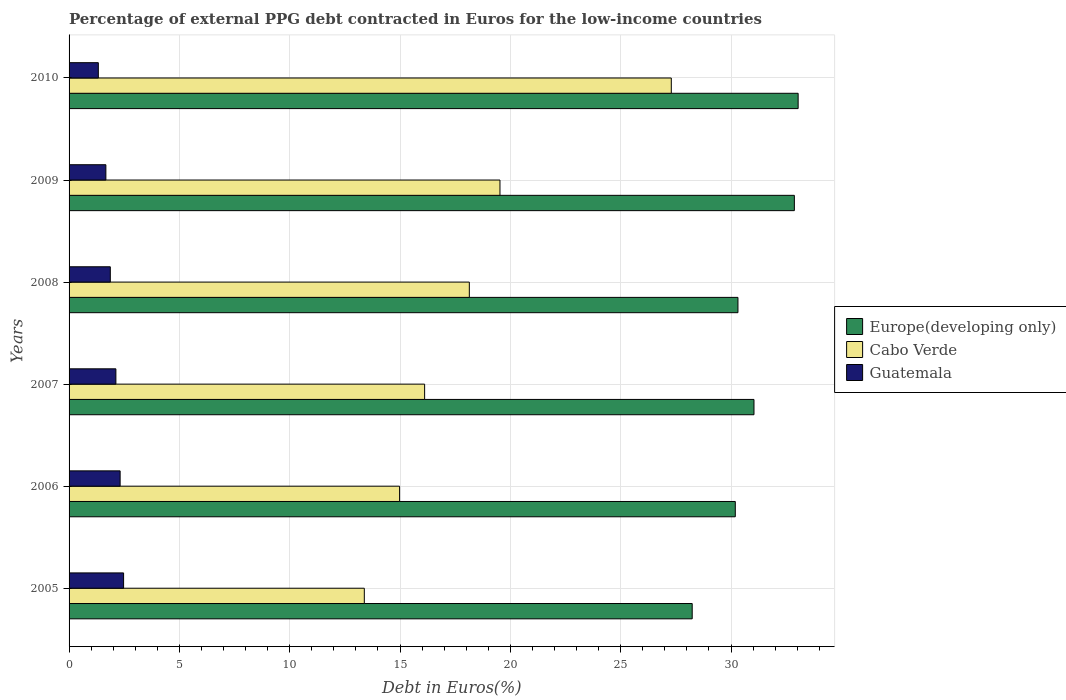Are the number of bars per tick equal to the number of legend labels?
Provide a succinct answer. Yes. How many bars are there on the 3rd tick from the top?
Make the answer very short. 3. What is the percentage of external PPG debt contracted in Euros in Cabo Verde in 2006?
Give a very brief answer. 14.98. Across all years, what is the maximum percentage of external PPG debt contracted in Euros in Cabo Verde?
Ensure brevity in your answer.  27.29. Across all years, what is the minimum percentage of external PPG debt contracted in Euros in Cabo Verde?
Make the answer very short. 13.38. What is the total percentage of external PPG debt contracted in Euros in Guatemala in the graph?
Give a very brief answer. 11.77. What is the difference between the percentage of external PPG debt contracted in Euros in Cabo Verde in 2006 and that in 2010?
Make the answer very short. -12.31. What is the difference between the percentage of external PPG debt contracted in Euros in Cabo Verde in 2010 and the percentage of external PPG debt contracted in Euros in Europe(developing only) in 2009?
Your answer should be very brief. -5.58. What is the average percentage of external PPG debt contracted in Euros in Guatemala per year?
Offer a very short reply. 1.96. In the year 2005, what is the difference between the percentage of external PPG debt contracted in Euros in Guatemala and percentage of external PPG debt contracted in Euros in Europe(developing only)?
Offer a very short reply. -25.77. What is the ratio of the percentage of external PPG debt contracted in Euros in Europe(developing only) in 2005 to that in 2008?
Your answer should be very brief. 0.93. What is the difference between the highest and the second highest percentage of external PPG debt contracted in Euros in Guatemala?
Offer a terse response. 0.16. What is the difference between the highest and the lowest percentage of external PPG debt contracted in Euros in Europe(developing only)?
Provide a succinct answer. 4.8. What does the 1st bar from the top in 2009 represents?
Your answer should be compact. Guatemala. What does the 2nd bar from the bottom in 2010 represents?
Provide a short and direct response. Cabo Verde. Is it the case that in every year, the sum of the percentage of external PPG debt contracted in Euros in Guatemala and percentage of external PPG debt contracted in Euros in Europe(developing only) is greater than the percentage of external PPG debt contracted in Euros in Cabo Verde?
Ensure brevity in your answer.  Yes. How many bars are there?
Your answer should be compact. 18. Are all the bars in the graph horizontal?
Your answer should be compact. Yes. What is the difference between two consecutive major ticks on the X-axis?
Your response must be concise. 5. Does the graph contain grids?
Ensure brevity in your answer.  Yes. Where does the legend appear in the graph?
Give a very brief answer. Center right. How are the legend labels stacked?
Make the answer very short. Vertical. What is the title of the graph?
Provide a succinct answer. Percentage of external PPG debt contracted in Euros for the low-income countries. What is the label or title of the X-axis?
Your answer should be very brief. Debt in Euros(%). What is the label or title of the Y-axis?
Your answer should be compact. Years. What is the Debt in Euros(%) of Europe(developing only) in 2005?
Your answer should be very brief. 28.24. What is the Debt in Euros(%) in Cabo Verde in 2005?
Offer a terse response. 13.38. What is the Debt in Euros(%) in Guatemala in 2005?
Offer a terse response. 2.47. What is the Debt in Euros(%) of Europe(developing only) in 2006?
Ensure brevity in your answer.  30.19. What is the Debt in Euros(%) in Cabo Verde in 2006?
Keep it short and to the point. 14.98. What is the Debt in Euros(%) in Guatemala in 2006?
Make the answer very short. 2.31. What is the Debt in Euros(%) of Europe(developing only) in 2007?
Offer a very short reply. 31.04. What is the Debt in Euros(%) of Cabo Verde in 2007?
Offer a terse response. 16.11. What is the Debt in Euros(%) in Guatemala in 2007?
Ensure brevity in your answer.  2.12. What is the Debt in Euros(%) in Europe(developing only) in 2008?
Provide a succinct answer. 30.31. What is the Debt in Euros(%) of Cabo Verde in 2008?
Provide a succinct answer. 18.14. What is the Debt in Euros(%) of Guatemala in 2008?
Make the answer very short. 1.87. What is the Debt in Euros(%) of Europe(developing only) in 2009?
Your response must be concise. 32.87. What is the Debt in Euros(%) in Cabo Verde in 2009?
Make the answer very short. 19.53. What is the Debt in Euros(%) of Guatemala in 2009?
Your answer should be very brief. 1.67. What is the Debt in Euros(%) of Europe(developing only) in 2010?
Offer a very short reply. 33.04. What is the Debt in Euros(%) in Cabo Verde in 2010?
Your answer should be very brief. 27.29. What is the Debt in Euros(%) in Guatemala in 2010?
Make the answer very short. 1.33. Across all years, what is the maximum Debt in Euros(%) in Europe(developing only)?
Provide a succinct answer. 33.04. Across all years, what is the maximum Debt in Euros(%) in Cabo Verde?
Make the answer very short. 27.29. Across all years, what is the maximum Debt in Euros(%) in Guatemala?
Keep it short and to the point. 2.47. Across all years, what is the minimum Debt in Euros(%) of Europe(developing only)?
Keep it short and to the point. 28.24. Across all years, what is the minimum Debt in Euros(%) of Cabo Verde?
Offer a terse response. 13.38. Across all years, what is the minimum Debt in Euros(%) in Guatemala?
Keep it short and to the point. 1.33. What is the total Debt in Euros(%) in Europe(developing only) in the graph?
Make the answer very short. 185.71. What is the total Debt in Euros(%) in Cabo Verde in the graph?
Your answer should be very brief. 109.44. What is the total Debt in Euros(%) in Guatemala in the graph?
Keep it short and to the point. 11.77. What is the difference between the Debt in Euros(%) of Europe(developing only) in 2005 and that in 2006?
Your response must be concise. -1.95. What is the difference between the Debt in Euros(%) of Cabo Verde in 2005 and that in 2006?
Offer a very short reply. -1.6. What is the difference between the Debt in Euros(%) in Guatemala in 2005 and that in 2006?
Your answer should be very brief. 0.16. What is the difference between the Debt in Euros(%) in Europe(developing only) in 2005 and that in 2007?
Make the answer very short. -2.8. What is the difference between the Debt in Euros(%) of Cabo Verde in 2005 and that in 2007?
Give a very brief answer. -2.73. What is the difference between the Debt in Euros(%) in Guatemala in 2005 and that in 2007?
Make the answer very short. 0.35. What is the difference between the Debt in Euros(%) of Europe(developing only) in 2005 and that in 2008?
Your answer should be compact. -2.07. What is the difference between the Debt in Euros(%) of Cabo Verde in 2005 and that in 2008?
Provide a succinct answer. -4.76. What is the difference between the Debt in Euros(%) in Guatemala in 2005 and that in 2008?
Make the answer very short. 0.6. What is the difference between the Debt in Euros(%) of Europe(developing only) in 2005 and that in 2009?
Your answer should be compact. -4.63. What is the difference between the Debt in Euros(%) of Cabo Verde in 2005 and that in 2009?
Provide a succinct answer. -6.15. What is the difference between the Debt in Euros(%) of Guatemala in 2005 and that in 2009?
Give a very brief answer. 0.8. What is the difference between the Debt in Euros(%) of Europe(developing only) in 2005 and that in 2010?
Your response must be concise. -4.8. What is the difference between the Debt in Euros(%) of Cabo Verde in 2005 and that in 2010?
Your answer should be compact. -13.91. What is the difference between the Debt in Euros(%) of Guatemala in 2005 and that in 2010?
Offer a terse response. 1.14. What is the difference between the Debt in Euros(%) of Europe(developing only) in 2006 and that in 2007?
Offer a very short reply. -0.85. What is the difference between the Debt in Euros(%) of Cabo Verde in 2006 and that in 2007?
Your answer should be very brief. -1.14. What is the difference between the Debt in Euros(%) of Guatemala in 2006 and that in 2007?
Ensure brevity in your answer.  0.19. What is the difference between the Debt in Euros(%) in Europe(developing only) in 2006 and that in 2008?
Provide a succinct answer. -0.12. What is the difference between the Debt in Euros(%) in Cabo Verde in 2006 and that in 2008?
Keep it short and to the point. -3.16. What is the difference between the Debt in Euros(%) in Guatemala in 2006 and that in 2008?
Your response must be concise. 0.44. What is the difference between the Debt in Euros(%) in Europe(developing only) in 2006 and that in 2009?
Keep it short and to the point. -2.68. What is the difference between the Debt in Euros(%) in Cabo Verde in 2006 and that in 2009?
Your answer should be compact. -4.55. What is the difference between the Debt in Euros(%) in Guatemala in 2006 and that in 2009?
Ensure brevity in your answer.  0.65. What is the difference between the Debt in Euros(%) in Europe(developing only) in 2006 and that in 2010?
Your answer should be compact. -2.85. What is the difference between the Debt in Euros(%) of Cabo Verde in 2006 and that in 2010?
Provide a short and direct response. -12.31. What is the difference between the Debt in Euros(%) in Guatemala in 2006 and that in 2010?
Provide a short and direct response. 0.99. What is the difference between the Debt in Euros(%) in Europe(developing only) in 2007 and that in 2008?
Provide a short and direct response. 0.73. What is the difference between the Debt in Euros(%) of Cabo Verde in 2007 and that in 2008?
Offer a very short reply. -2.03. What is the difference between the Debt in Euros(%) in Guatemala in 2007 and that in 2008?
Provide a succinct answer. 0.25. What is the difference between the Debt in Euros(%) in Europe(developing only) in 2007 and that in 2009?
Keep it short and to the point. -1.83. What is the difference between the Debt in Euros(%) of Cabo Verde in 2007 and that in 2009?
Your answer should be very brief. -3.42. What is the difference between the Debt in Euros(%) of Guatemala in 2007 and that in 2009?
Provide a short and direct response. 0.45. What is the difference between the Debt in Euros(%) in Europe(developing only) in 2007 and that in 2010?
Make the answer very short. -2. What is the difference between the Debt in Euros(%) in Cabo Verde in 2007 and that in 2010?
Your answer should be very brief. -11.18. What is the difference between the Debt in Euros(%) of Guatemala in 2007 and that in 2010?
Offer a very short reply. 0.8. What is the difference between the Debt in Euros(%) in Europe(developing only) in 2008 and that in 2009?
Offer a very short reply. -2.56. What is the difference between the Debt in Euros(%) of Cabo Verde in 2008 and that in 2009?
Your answer should be compact. -1.39. What is the difference between the Debt in Euros(%) in Guatemala in 2008 and that in 2009?
Keep it short and to the point. 0.2. What is the difference between the Debt in Euros(%) in Europe(developing only) in 2008 and that in 2010?
Your answer should be compact. -2.73. What is the difference between the Debt in Euros(%) of Cabo Verde in 2008 and that in 2010?
Ensure brevity in your answer.  -9.15. What is the difference between the Debt in Euros(%) in Guatemala in 2008 and that in 2010?
Ensure brevity in your answer.  0.54. What is the difference between the Debt in Euros(%) in Europe(developing only) in 2009 and that in 2010?
Provide a succinct answer. -0.17. What is the difference between the Debt in Euros(%) of Cabo Verde in 2009 and that in 2010?
Offer a terse response. -7.76. What is the difference between the Debt in Euros(%) in Guatemala in 2009 and that in 2010?
Provide a succinct answer. 0.34. What is the difference between the Debt in Euros(%) of Europe(developing only) in 2005 and the Debt in Euros(%) of Cabo Verde in 2006?
Provide a short and direct response. 13.26. What is the difference between the Debt in Euros(%) in Europe(developing only) in 2005 and the Debt in Euros(%) in Guatemala in 2006?
Offer a very short reply. 25.93. What is the difference between the Debt in Euros(%) in Cabo Verde in 2005 and the Debt in Euros(%) in Guatemala in 2006?
Your response must be concise. 11.07. What is the difference between the Debt in Euros(%) of Europe(developing only) in 2005 and the Debt in Euros(%) of Cabo Verde in 2007?
Provide a short and direct response. 12.13. What is the difference between the Debt in Euros(%) in Europe(developing only) in 2005 and the Debt in Euros(%) in Guatemala in 2007?
Ensure brevity in your answer.  26.12. What is the difference between the Debt in Euros(%) of Cabo Verde in 2005 and the Debt in Euros(%) of Guatemala in 2007?
Your response must be concise. 11.26. What is the difference between the Debt in Euros(%) in Europe(developing only) in 2005 and the Debt in Euros(%) in Cabo Verde in 2008?
Offer a very short reply. 10.1. What is the difference between the Debt in Euros(%) in Europe(developing only) in 2005 and the Debt in Euros(%) in Guatemala in 2008?
Provide a short and direct response. 26.37. What is the difference between the Debt in Euros(%) in Cabo Verde in 2005 and the Debt in Euros(%) in Guatemala in 2008?
Ensure brevity in your answer.  11.51. What is the difference between the Debt in Euros(%) of Europe(developing only) in 2005 and the Debt in Euros(%) of Cabo Verde in 2009?
Make the answer very short. 8.71. What is the difference between the Debt in Euros(%) of Europe(developing only) in 2005 and the Debt in Euros(%) of Guatemala in 2009?
Give a very brief answer. 26.57. What is the difference between the Debt in Euros(%) in Cabo Verde in 2005 and the Debt in Euros(%) in Guatemala in 2009?
Make the answer very short. 11.71. What is the difference between the Debt in Euros(%) in Europe(developing only) in 2005 and the Debt in Euros(%) in Cabo Verde in 2010?
Offer a very short reply. 0.95. What is the difference between the Debt in Euros(%) of Europe(developing only) in 2005 and the Debt in Euros(%) of Guatemala in 2010?
Your response must be concise. 26.92. What is the difference between the Debt in Euros(%) in Cabo Verde in 2005 and the Debt in Euros(%) in Guatemala in 2010?
Your response must be concise. 12.05. What is the difference between the Debt in Euros(%) of Europe(developing only) in 2006 and the Debt in Euros(%) of Cabo Verde in 2007?
Ensure brevity in your answer.  14.08. What is the difference between the Debt in Euros(%) in Europe(developing only) in 2006 and the Debt in Euros(%) in Guatemala in 2007?
Your answer should be very brief. 28.07. What is the difference between the Debt in Euros(%) of Cabo Verde in 2006 and the Debt in Euros(%) of Guatemala in 2007?
Your answer should be compact. 12.86. What is the difference between the Debt in Euros(%) in Europe(developing only) in 2006 and the Debt in Euros(%) in Cabo Verde in 2008?
Your response must be concise. 12.05. What is the difference between the Debt in Euros(%) of Europe(developing only) in 2006 and the Debt in Euros(%) of Guatemala in 2008?
Offer a very short reply. 28.33. What is the difference between the Debt in Euros(%) of Cabo Verde in 2006 and the Debt in Euros(%) of Guatemala in 2008?
Provide a succinct answer. 13.11. What is the difference between the Debt in Euros(%) in Europe(developing only) in 2006 and the Debt in Euros(%) in Cabo Verde in 2009?
Your answer should be compact. 10.66. What is the difference between the Debt in Euros(%) in Europe(developing only) in 2006 and the Debt in Euros(%) in Guatemala in 2009?
Give a very brief answer. 28.53. What is the difference between the Debt in Euros(%) of Cabo Verde in 2006 and the Debt in Euros(%) of Guatemala in 2009?
Make the answer very short. 13.31. What is the difference between the Debt in Euros(%) of Europe(developing only) in 2006 and the Debt in Euros(%) of Cabo Verde in 2010?
Provide a succinct answer. 2.9. What is the difference between the Debt in Euros(%) of Europe(developing only) in 2006 and the Debt in Euros(%) of Guatemala in 2010?
Provide a succinct answer. 28.87. What is the difference between the Debt in Euros(%) in Cabo Verde in 2006 and the Debt in Euros(%) in Guatemala in 2010?
Give a very brief answer. 13.65. What is the difference between the Debt in Euros(%) in Europe(developing only) in 2007 and the Debt in Euros(%) in Cabo Verde in 2008?
Ensure brevity in your answer.  12.9. What is the difference between the Debt in Euros(%) in Europe(developing only) in 2007 and the Debt in Euros(%) in Guatemala in 2008?
Provide a succinct answer. 29.17. What is the difference between the Debt in Euros(%) of Cabo Verde in 2007 and the Debt in Euros(%) of Guatemala in 2008?
Your answer should be compact. 14.25. What is the difference between the Debt in Euros(%) of Europe(developing only) in 2007 and the Debt in Euros(%) of Cabo Verde in 2009?
Provide a short and direct response. 11.51. What is the difference between the Debt in Euros(%) of Europe(developing only) in 2007 and the Debt in Euros(%) of Guatemala in 2009?
Offer a very short reply. 29.37. What is the difference between the Debt in Euros(%) in Cabo Verde in 2007 and the Debt in Euros(%) in Guatemala in 2009?
Your response must be concise. 14.45. What is the difference between the Debt in Euros(%) in Europe(developing only) in 2007 and the Debt in Euros(%) in Cabo Verde in 2010?
Provide a short and direct response. 3.75. What is the difference between the Debt in Euros(%) in Europe(developing only) in 2007 and the Debt in Euros(%) in Guatemala in 2010?
Keep it short and to the point. 29.72. What is the difference between the Debt in Euros(%) of Cabo Verde in 2007 and the Debt in Euros(%) of Guatemala in 2010?
Offer a very short reply. 14.79. What is the difference between the Debt in Euros(%) in Europe(developing only) in 2008 and the Debt in Euros(%) in Cabo Verde in 2009?
Offer a terse response. 10.79. What is the difference between the Debt in Euros(%) in Europe(developing only) in 2008 and the Debt in Euros(%) in Guatemala in 2009?
Keep it short and to the point. 28.65. What is the difference between the Debt in Euros(%) of Cabo Verde in 2008 and the Debt in Euros(%) of Guatemala in 2009?
Offer a very short reply. 16.47. What is the difference between the Debt in Euros(%) in Europe(developing only) in 2008 and the Debt in Euros(%) in Cabo Verde in 2010?
Your response must be concise. 3.02. What is the difference between the Debt in Euros(%) of Europe(developing only) in 2008 and the Debt in Euros(%) of Guatemala in 2010?
Your answer should be very brief. 28.99. What is the difference between the Debt in Euros(%) in Cabo Verde in 2008 and the Debt in Euros(%) in Guatemala in 2010?
Offer a very short reply. 16.81. What is the difference between the Debt in Euros(%) in Europe(developing only) in 2009 and the Debt in Euros(%) in Cabo Verde in 2010?
Offer a very short reply. 5.58. What is the difference between the Debt in Euros(%) of Europe(developing only) in 2009 and the Debt in Euros(%) of Guatemala in 2010?
Give a very brief answer. 31.55. What is the difference between the Debt in Euros(%) of Cabo Verde in 2009 and the Debt in Euros(%) of Guatemala in 2010?
Your answer should be compact. 18.2. What is the average Debt in Euros(%) of Europe(developing only) per year?
Your response must be concise. 30.95. What is the average Debt in Euros(%) of Cabo Verde per year?
Provide a succinct answer. 18.24. What is the average Debt in Euros(%) in Guatemala per year?
Offer a terse response. 1.96. In the year 2005, what is the difference between the Debt in Euros(%) of Europe(developing only) and Debt in Euros(%) of Cabo Verde?
Offer a terse response. 14.86. In the year 2005, what is the difference between the Debt in Euros(%) in Europe(developing only) and Debt in Euros(%) in Guatemala?
Offer a terse response. 25.77. In the year 2005, what is the difference between the Debt in Euros(%) in Cabo Verde and Debt in Euros(%) in Guatemala?
Your response must be concise. 10.91. In the year 2006, what is the difference between the Debt in Euros(%) in Europe(developing only) and Debt in Euros(%) in Cabo Verde?
Your answer should be very brief. 15.22. In the year 2006, what is the difference between the Debt in Euros(%) in Europe(developing only) and Debt in Euros(%) in Guatemala?
Offer a very short reply. 27.88. In the year 2006, what is the difference between the Debt in Euros(%) of Cabo Verde and Debt in Euros(%) of Guatemala?
Offer a very short reply. 12.67. In the year 2007, what is the difference between the Debt in Euros(%) in Europe(developing only) and Debt in Euros(%) in Cabo Verde?
Ensure brevity in your answer.  14.93. In the year 2007, what is the difference between the Debt in Euros(%) of Europe(developing only) and Debt in Euros(%) of Guatemala?
Your response must be concise. 28.92. In the year 2007, what is the difference between the Debt in Euros(%) of Cabo Verde and Debt in Euros(%) of Guatemala?
Give a very brief answer. 13.99. In the year 2008, what is the difference between the Debt in Euros(%) in Europe(developing only) and Debt in Euros(%) in Cabo Verde?
Your answer should be very brief. 12.17. In the year 2008, what is the difference between the Debt in Euros(%) of Europe(developing only) and Debt in Euros(%) of Guatemala?
Provide a short and direct response. 28.45. In the year 2008, what is the difference between the Debt in Euros(%) of Cabo Verde and Debt in Euros(%) of Guatemala?
Provide a short and direct response. 16.27. In the year 2009, what is the difference between the Debt in Euros(%) in Europe(developing only) and Debt in Euros(%) in Cabo Verde?
Offer a terse response. 13.34. In the year 2009, what is the difference between the Debt in Euros(%) of Europe(developing only) and Debt in Euros(%) of Guatemala?
Your answer should be compact. 31.2. In the year 2009, what is the difference between the Debt in Euros(%) of Cabo Verde and Debt in Euros(%) of Guatemala?
Give a very brief answer. 17.86. In the year 2010, what is the difference between the Debt in Euros(%) of Europe(developing only) and Debt in Euros(%) of Cabo Verde?
Offer a terse response. 5.75. In the year 2010, what is the difference between the Debt in Euros(%) in Europe(developing only) and Debt in Euros(%) in Guatemala?
Your answer should be very brief. 31.72. In the year 2010, what is the difference between the Debt in Euros(%) of Cabo Verde and Debt in Euros(%) of Guatemala?
Provide a short and direct response. 25.97. What is the ratio of the Debt in Euros(%) in Europe(developing only) in 2005 to that in 2006?
Your answer should be very brief. 0.94. What is the ratio of the Debt in Euros(%) of Cabo Verde in 2005 to that in 2006?
Your answer should be compact. 0.89. What is the ratio of the Debt in Euros(%) of Guatemala in 2005 to that in 2006?
Keep it short and to the point. 1.07. What is the ratio of the Debt in Euros(%) in Europe(developing only) in 2005 to that in 2007?
Provide a succinct answer. 0.91. What is the ratio of the Debt in Euros(%) of Cabo Verde in 2005 to that in 2007?
Your response must be concise. 0.83. What is the ratio of the Debt in Euros(%) in Guatemala in 2005 to that in 2007?
Offer a terse response. 1.16. What is the ratio of the Debt in Euros(%) in Europe(developing only) in 2005 to that in 2008?
Provide a succinct answer. 0.93. What is the ratio of the Debt in Euros(%) of Cabo Verde in 2005 to that in 2008?
Provide a short and direct response. 0.74. What is the ratio of the Debt in Euros(%) of Guatemala in 2005 to that in 2008?
Provide a succinct answer. 1.32. What is the ratio of the Debt in Euros(%) in Europe(developing only) in 2005 to that in 2009?
Your answer should be very brief. 0.86. What is the ratio of the Debt in Euros(%) of Cabo Verde in 2005 to that in 2009?
Your response must be concise. 0.69. What is the ratio of the Debt in Euros(%) of Guatemala in 2005 to that in 2009?
Your answer should be compact. 1.48. What is the ratio of the Debt in Euros(%) in Europe(developing only) in 2005 to that in 2010?
Provide a succinct answer. 0.85. What is the ratio of the Debt in Euros(%) in Cabo Verde in 2005 to that in 2010?
Provide a short and direct response. 0.49. What is the ratio of the Debt in Euros(%) in Guatemala in 2005 to that in 2010?
Your answer should be compact. 1.86. What is the ratio of the Debt in Euros(%) in Europe(developing only) in 2006 to that in 2007?
Give a very brief answer. 0.97. What is the ratio of the Debt in Euros(%) in Cabo Verde in 2006 to that in 2007?
Your response must be concise. 0.93. What is the ratio of the Debt in Euros(%) of Guatemala in 2006 to that in 2007?
Give a very brief answer. 1.09. What is the ratio of the Debt in Euros(%) of Europe(developing only) in 2006 to that in 2008?
Provide a succinct answer. 1. What is the ratio of the Debt in Euros(%) in Cabo Verde in 2006 to that in 2008?
Provide a short and direct response. 0.83. What is the ratio of the Debt in Euros(%) of Guatemala in 2006 to that in 2008?
Make the answer very short. 1.24. What is the ratio of the Debt in Euros(%) of Europe(developing only) in 2006 to that in 2009?
Give a very brief answer. 0.92. What is the ratio of the Debt in Euros(%) of Cabo Verde in 2006 to that in 2009?
Your response must be concise. 0.77. What is the ratio of the Debt in Euros(%) in Guatemala in 2006 to that in 2009?
Give a very brief answer. 1.39. What is the ratio of the Debt in Euros(%) in Europe(developing only) in 2006 to that in 2010?
Your answer should be very brief. 0.91. What is the ratio of the Debt in Euros(%) of Cabo Verde in 2006 to that in 2010?
Give a very brief answer. 0.55. What is the ratio of the Debt in Euros(%) in Guatemala in 2006 to that in 2010?
Make the answer very short. 1.74. What is the ratio of the Debt in Euros(%) of Cabo Verde in 2007 to that in 2008?
Your answer should be very brief. 0.89. What is the ratio of the Debt in Euros(%) of Guatemala in 2007 to that in 2008?
Your answer should be compact. 1.14. What is the ratio of the Debt in Euros(%) of Europe(developing only) in 2007 to that in 2009?
Ensure brevity in your answer.  0.94. What is the ratio of the Debt in Euros(%) in Cabo Verde in 2007 to that in 2009?
Give a very brief answer. 0.83. What is the ratio of the Debt in Euros(%) of Guatemala in 2007 to that in 2009?
Your answer should be compact. 1.27. What is the ratio of the Debt in Euros(%) of Europe(developing only) in 2007 to that in 2010?
Make the answer very short. 0.94. What is the ratio of the Debt in Euros(%) in Cabo Verde in 2007 to that in 2010?
Give a very brief answer. 0.59. What is the ratio of the Debt in Euros(%) of Guatemala in 2007 to that in 2010?
Provide a short and direct response. 1.6. What is the ratio of the Debt in Euros(%) of Europe(developing only) in 2008 to that in 2009?
Your answer should be very brief. 0.92. What is the ratio of the Debt in Euros(%) in Cabo Verde in 2008 to that in 2009?
Give a very brief answer. 0.93. What is the ratio of the Debt in Euros(%) in Guatemala in 2008 to that in 2009?
Make the answer very short. 1.12. What is the ratio of the Debt in Euros(%) in Europe(developing only) in 2008 to that in 2010?
Make the answer very short. 0.92. What is the ratio of the Debt in Euros(%) in Cabo Verde in 2008 to that in 2010?
Keep it short and to the point. 0.66. What is the ratio of the Debt in Euros(%) of Guatemala in 2008 to that in 2010?
Offer a terse response. 1.41. What is the ratio of the Debt in Euros(%) of Europe(developing only) in 2009 to that in 2010?
Provide a short and direct response. 0.99. What is the ratio of the Debt in Euros(%) in Cabo Verde in 2009 to that in 2010?
Provide a succinct answer. 0.72. What is the ratio of the Debt in Euros(%) in Guatemala in 2009 to that in 2010?
Provide a succinct answer. 1.26. What is the difference between the highest and the second highest Debt in Euros(%) of Europe(developing only)?
Give a very brief answer. 0.17. What is the difference between the highest and the second highest Debt in Euros(%) in Cabo Verde?
Make the answer very short. 7.76. What is the difference between the highest and the second highest Debt in Euros(%) in Guatemala?
Provide a succinct answer. 0.16. What is the difference between the highest and the lowest Debt in Euros(%) of Europe(developing only)?
Keep it short and to the point. 4.8. What is the difference between the highest and the lowest Debt in Euros(%) in Cabo Verde?
Make the answer very short. 13.91. What is the difference between the highest and the lowest Debt in Euros(%) in Guatemala?
Offer a terse response. 1.14. 